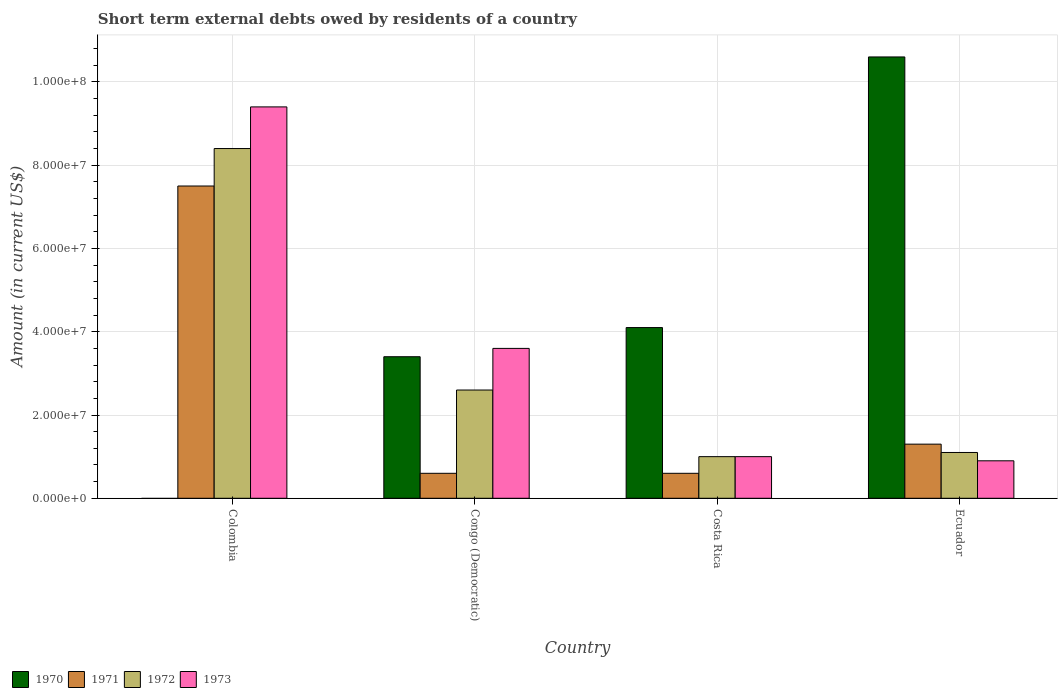How many different coloured bars are there?
Provide a succinct answer. 4. How many groups of bars are there?
Make the answer very short. 4. What is the label of the 4th group of bars from the left?
Provide a succinct answer. Ecuador. Across all countries, what is the maximum amount of short-term external debts owed by residents in 1973?
Your answer should be compact. 9.40e+07. Across all countries, what is the minimum amount of short-term external debts owed by residents in 1970?
Ensure brevity in your answer.  0. What is the total amount of short-term external debts owed by residents in 1972 in the graph?
Give a very brief answer. 1.31e+08. What is the difference between the amount of short-term external debts owed by residents in 1973 in Colombia and that in Ecuador?
Offer a very short reply. 8.50e+07. What is the difference between the amount of short-term external debts owed by residents in 1970 in Congo (Democratic) and the amount of short-term external debts owed by residents in 1973 in Colombia?
Ensure brevity in your answer.  -6.00e+07. What is the average amount of short-term external debts owed by residents in 1973 per country?
Ensure brevity in your answer.  3.72e+07. What is the difference between the amount of short-term external debts owed by residents of/in 1972 and amount of short-term external debts owed by residents of/in 1973 in Colombia?
Make the answer very short. -1.00e+07. In how many countries, is the amount of short-term external debts owed by residents in 1971 greater than 92000000 US$?
Ensure brevity in your answer.  0. What is the ratio of the amount of short-term external debts owed by residents in 1970 in Costa Rica to that in Ecuador?
Make the answer very short. 0.39. Is the amount of short-term external debts owed by residents in 1973 in Costa Rica less than that in Ecuador?
Offer a terse response. No. What is the difference between the highest and the second highest amount of short-term external debts owed by residents in 1973?
Give a very brief answer. 5.80e+07. What is the difference between the highest and the lowest amount of short-term external debts owed by residents in 1970?
Offer a terse response. 1.06e+08. Is it the case that in every country, the sum of the amount of short-term external debts owed by residents in 1973 and amount of short-term external debts owed by residents in 1972 is greater than the sum of amount of short-term external debts owed by residents in 1970 and amount of short-term external debts owed by residents in 1971?
Provide a short and direct response. No. How many bars are there?
Ensure brevity in your answer.  15. How many countries are there in the graph?
Your response must be concise. 4. What is the difference between two consecutive major ticks on the Y-axis?
Make the answer very short. 2.00e+07. Where does the legend appear in the graph?
Offer a terse response. Bottom left. How many legend labels are there?
Your answer should be very brief. 4. What is the title of the graph?
Make the answer very short. Short term external debts owed by residents of a country. Does "2011" appear as one of the legend labels in the graph?
Offer a terse response. No. What is the Amount (in current US$) of 1970 in Colombia?
Ensure brevity in your answer.  0. What is the Amount (in current US$) in 1971 in Colombia?
Your answer should be compact. 7.50e+07. What is the Amount (in current US$) of 1972 in Colombia?
Your response must be concise. 8.40e+07. What is the Amount (in current US$) of 1973 in Colombia?
Offer a terse response. 9.40e+07. What is the Amount (in current US$) of 1970 in Congo (Democratic)?
Your answer should be compact. 3.40e+07. What is the Amount (in current US$) of 1972 in Congo (Democratic)?
Give a very brief answer. 2.60e+07. What is the Amount (in current US$) in 1973 in Congo (Democratic)?
Provide a succinct answer. 3.60e+07. What is the Amount (in current US$) in 1970 in Costa Rica?
Your answer should be very brief. 4.10e+07. What is the Amount (in current US$) of 1971 in Costa Rica?
Offer a very short reply. 6.00e+06. What is the Amount (in current US$) of 1972 in Costa Rica?
Your answer should be very brief. 1.00e+07. What is the Amount (in current US$) of 1970 in Ecuador?
Offer a terse response. 1.06e+08. What is the Amount (in current US$) of 1971 in Ecuador?
Offer a terse response. 1.30e+07. What is the Amount (in current US$) in 1972 in Ecuador?
Your answer should be compact. 1.10e+07. What is the Amount (in current US$) in 1973 in Ecuador?
Make the answer very short. 9.00e+06. Across all countries, what is the maximum Amount (in current US$) of 1970?
Your answer should be compact. 1.06e+08. Across all countries, what is the maximum Amount (in current US$) of 1971?
Give a very brief answer. 7.50e+07. Across all countries, what is the maximum Amount (in current US$) of 1972?
Offer a very short reply. 8.40e+07. Across all countries, what is the maximum Amount (in current US$) of 1973?
Keep it short and to the point. 9.40e+07. Across all countries, what is the minimum Amount (in current US$) in 1972?
Provide a short and direct response. 1.00e+07. Across all countries, what is the minimum Amount (in current US$) of 1973?
Your answer should be compact. 9.00e+06. What is the total Amount (in current US$) of 1970 in the graph?
Provide a succinct answer. 1.81e+08. What is the total Amount (in current US$) of 1971 in the graph?
Make the answer very short. 1.00e+08. What is the total Amount (in current US$) of 1972 in the graph?
Ensure brevity in your answer.  1.31e+08. What is the total Amount (in current US$) of 1973 in the graph?
Ensure brevity in your answer.  1.49e+08. What is the difference between the Amount (in current US$) of 1971 in Colombia and that in Congo (Democratic)?
Your answer should be very brief. 6.90e+07. What is the difference between the Amount (in current US$) of 1972 in Colombia and that in Congo (Democratic)?
Provide a succinct answer. 5.80e+07. What is the difference between the Amount (in current US$) in 1973 in Colombia and that in Congo (Democratic)?
Provide a short and direct response. 5.80e+07. What is the difference between the Amount (in current US$) in 1971 in Colombia and that in Costa Rica?
Give a very brief answer. 6.90e+07. What is the difference between the Amount (in current US$) in 1972 in Colombia and that in Costa Rica?
Your response must be concise. 7.40e+07. What is the difference between the Amount (in current US$) of 1973 in Colombia and that in Costa Rica?
Your answer should be very brief. 8.40e+07. What is the difference between the Amount (in current US$) of 1971 in Colombia and that in Ecuador?
Provide a succinct answer. 6.20e+07. What is the difference between the Amount (in current US$) in 1972 in Colombia and that in Ecuador?
Make the answer very short. 7.30e+07. What is the difference between the Amount (in current US$) in 1973 in Colombia and that in Ecuador?
Make the answer very short. 8.50e+07. What is the difference between the Amount (in current US$) in 1970 in Congo (Democratic) and that in Costa Rica?
Your answer should be compact. -7.00e+06. What is the difference between the Amount (in current US$) of 1971 in Congo (Democratic) and that in Costa Rica?
Give a very brief answer. 0. What is the difference between the Amount (in current US$) of 1972 in Congo (Democratic) and that in Costa Rica?
Your answer should be very brief. 1.60e+07. What is the difference between the Amount (in current US$) in 1973 in Congo (Democratic) and that in Costa Rica?
Provide a short and direct response. 2.60e+07. What is the difference between the Amount (in current US$) of 1970 in Congo (Democratic) and that in Ecuador?
Your response must be concise. -7.20e+07. What is the difference between the Amount (in current US$) in 1971 in Congo (Democratic) and that in Ecuador?
Provide a short and direct response. -7.00e+06. What is the difference between the Amount (in current US$) of 1972 in Congo (Democratic) and that in Ecuador?
Make the answer very short. 1.50e+07. What is the difference between the Amount (in current US$) in 1973 in Congo (Democratic) and that in Ecuador?
Ensure brevity in your answer.  2.70e+07. What is the difference between the Amount (in current US$) in 1970 in Costa Rica and that in Ecuador?
Offer a terse response. -6.50e+07. What is the difference between the Amount (in current US$) in 1971 in Costa Rica and that in Ecuador?
Ensure brevity in your answer.  -7.00e+06. What is the difference between the Amount (in current US$) of 1972 in Costa Rica and that in Ecuador?
Ensure brevity in your answer.  -1.00e+06. What is the difference between the Amount (in current US$) in 1971 in Colombia and the Amount (in current US$) in 1972 in Congo (Democratic)?
Ensure brevity in your answer.  4.90e+07. What is the difference between the Amount (in current US$) in 1971 in Colombia and the Amount (in current US$) in 1973 in Congo (Democratic)?
Offer a terse response. 3.90e+07. What is the difference between the Amount (in current US$) of 1972 in Colombia and the Amount (in current US$) of 1973 in Congo (Democratic)?
Ensure brevity in your answer.  4.80e+07. What is the difference between the Amount (in current US$) of 1971 in Colombia and the Amount (in current US$) of 1972 in Costa Rica?
Offer a terse response. 6.50e+07. What is the difference between the Amount (in current US$) of 1971 in Colombia and the Amount (in current US$) of 1973 in Costa Rica?
Give a very brief answer. 6.50e+07. What is the difference between the Amount (in current US$) of 1972 in Colombia and the Amount (in current US$) of 1973 in Costa Rica?
Provide a short and direct response. 7.40e+07. What is the difference between the Amount (in current US$) of 1971 in Colombia and the Amount (in current US$) of 1972 in Ecuador?
Your answer should be compact. 6.40e+07. What is the difference between the Amount (in current US$) of 1971 in Colombia and the Amount (in current US$) of 1973 in Ecuador?
Your response must be concise. 6.60e+07. What is the difference between the Amount (in current US$) of 1972 in Colombia and the Amount (in current US$) of 1973 in Ecuador?
Offer a very short reply. 7.50e+07. What is the difference between the Amount (in current US$) in 1970 in Congo (Democratic) and the Amount (in current US$) in 1971 in Costa Rica?
Give a very brief answer. 2.80e+07. What is the difference between the Amount (in current US$) of 1970 in Congo (Democratic) and the Amount (in current US$) of 1972 in Costa Rica?
Your answer should be compact. 2.40e+07. What is the difference between the Amount (in current US$) in 1970 in Congo (Democratic) and the Amount (in current US$) in 1973 in Costa Rica?
Your response must be concise. 2.40e+07. What is the difference between the Amount (in current US$) of 1972 in Congo (Democratic) and the Amount (in current US$) of 1973 in Costa Rica?
Give a very brief answer. 1.60e+07. What is the difference between the Amount (in current US$) in 1970 in Congo (Democratic) and the Amount (in current US$) in 1971 in Ecuador?
Provide a succinct answer. 2.10e+07. What is the difference between the Amount (in current US$) of 1970 in Congo (Democratic) and the Amount (in current US$) of 1972 in Ecuador?
Offer a terse response. 2.30e+07. What is the difference between the Amount (in current US$) of 1970 in Congo (Democratic) and the Amount (in current US$) of 1973 in Ecuador?
Your answer should be very brief. 2.50e+07. What is the difference between the Amount (in current US$) of 1971 in Congo (Democratic) and the Amount (in current US$) of 1972 in Ecuador?
Your answer should be very brief. -5.00e+06. What is the difference between the Amount (in current US$) in 1972 in Congo (Democratic) and the Amount (in current US$) in 1973 in Ecuador?
Offer a terse response. 1.70e+07. What is the difference between the Amount (in current US$) in 1970 in Costa Rica and the Amount (in current US$) in 1971 in Ecuador?
Your response must be concise. 2.80e+07. What is the difference between the Amount (in current US$) of 1970 in Costa Rica and the Amount (in current US$) of 1972 in Ecuador?
Your response must be concise. 3.00e+07. What is the difference between the Amount (in current US$) in 1970 in Costa Rica and the Amount (in current US$) in 1973 in Ecuador?
Your answer should be compact. 3.20e+07. What is the difference between the Amount (in current US$) in 1971 in Costa Rica and the Amount (in current US$) in 1972 in Ecuador?
Offer a terse response. -5.00e+06. What is the difference between the Amount (in current US$) of 1971 in Costa Rica and the Amount (in current US$) of 1973 in Ecuador?
Provide a succinct answer. -3.00e+06. What is the difference between the Amount (in current US$) in 1972 in Costa Rica and the Amount (in current US$) in 1973 in Ecuador?
Offer a terse response. 1.00e+06. What is the average Amount (in current US$) of 1970 per country?
Offer a terse response. 4.52e+07. What is the average Amount (in current US$) of 1971 per country?
Keep it short and to the point. 2.50e+07. What is the average Amount (in current US$) in 1972 per country?
Provide a short and direct response. 3.28e+07. What is the average Amount (in current US$) in 1973 per country?
Make the answer very short. 3.72e+07. What is the difference between the Amount (in current US$) in 1971 and Amount (in current US$) in 1972 in Colombia?
Provide a succinct answer. -9.00e+06. What is the difference between the Amount (in current US$) in 1971 and Amount (in current US$) in 1973 in Colombia?
Offer a very short reply. -1.90e+07. What is the difference between the Amount (in current US$) of 1972 and Amount (in current US$) of 1973 in Colombia?
Your answer should be compact. -1.00e+07. What is the difference between the Amount (in current US$) of 1970 and Amount (in current US$) of 1971 in Congo (Democratic)?
Offer a very short reply. 2.80e+07. What is the difference between the Amount (in current US$) of 1970 and Amount (in current US$) of 1972 in Congo (Democratic)?
Your answer should be compact. 8.00e+06. What is the difference between the Amount (in current US$) in 1971 and Amount (in current US$) in 1972 in Congo (Democratic)?
Ensure brevity in your answer.  -2.00e+07. What is the difference between the Amount (in current US$) in 1971 and Amount (in current US$) in 1973 in Congo (Democratic)?
Ensure brevity in your answer.  -3.00e+07. What is the difference between the Amount (in current US$) in 1972 and Amount (in current US$) in 1973 in Congo (Democratic)?
Provide a succinct answer. -1.00e+07. What is the difference between the Amount (in current US$) of 1970 and Amount (in current US$) of 1971 in Costa Rica?
Your answer should be very brief. 3.50e+07. What is the difference between the Amount (in current US$) in 1970 and Amount (in current US$) in 1972 in Costa Rica?
Make the answer very short. 3.10e+07. What is the difference between the Amount (in current US$) in 1970 and Amount (in current US$) in 1973 in Costa Rica?
Offer a very short reply. 3.10e+07. What is the difference between the Amount (in current US$) in 1972 and Amount (in current US$) in 1973 in Costa Rica?
Provide a succinct answer. 0. What is the difference between the Amount (in current US$) of 1970 and Amount (in current US$) of 1971 in Ecuador?
Ensure brevity in your answer.  9.30e+07. What is the difference between the Amount (in current US$) in 1970 and Amount (in current US$) in 1972 in Ecuador?
Give a very brief answer. 9.50e+07. What is the difference between the Amount (in current US$) in 1970 and Amount (in current US$) in 1973 in Ecuador?
Provide a succinct answer. 9.70e+07. What is the difference between the Amount (in current US$) in 1971 and Amount (in current US$) in 1972 in Ecuador?
Your answer should be very brief. 2.00e+06. What is the difference between the Amount (in current US$) in 1972 and Amount (in current US$) in 1973 in Ecuador?
Your answer should be compact. 2.00e+06. What is the ratio of the Amount (in current US$) in 1971 in Colombia to that in Congo (Democratic)?
Make the answer very short. 12.5. What is the ratio of the Amount (in current US$) in 1972 in Colombia to that in Congo (Democratic)?
Make the answer very short. 3.23. What is the ratio of the Amount (in current US$) in 1973 in Colombia to that in Congo (Democratic)?
Your answer should be compact. 2.61. What is the ratio of the Amount (in current US$) in 1972 in Colombia to that in Costa Rica?
Give a very brief answer. 8.4. What is the ratio of the Amount (in current US$) of 1971 in Colombia to that in Ecuador?
Give a very brief answer. 5.77. What is the ratio of the Amount (in current US$) in 1972 in Colombia to that in Ecuador?
Offer a terse response. 7.64. What is the ratio of the Amount (in current US$) of 1973 in Colombia to that in Ecuador?
Provide a short and direct response. 10.44. What is the ratio of the Amount (in current US$) of 1970 in Congo (Democratic) to that in Costa Rica?
Your response must be concise. 0.83. What is the ratio of the Amount (in current US$) in 1972 in Congo (Democratic) to that in Costa Rica?
Ensure brevity in your answer.  2.6. What is the ratio of the Amount (in current US$) in 1973 in Congo (Democratic) to that in Costa Rica?
Provide a short and direct response. 3.6. What is the ratio of the Amount (in current US$) in 1970 in Congo (Democratic) to that in Ecuador?
Offer a very short reply. 0.32. What is the ratio of the Amount (in current US$) in 1971 in Congo (Democratic) to that in Ecuador?
Make the answer very short. 0.46. What is the ratio of the Amount (in current US$) in 1972 in Congo (Democratic) to that in Ecuador?
Offer a terse response. 2.36. What is the ratio of the Amount (in current US$) in 1970 in Costa Rica to that in Ecuador?
Offer a terse response. 0.39. What is the ratio of the Amount (in current US$) in 1971 in Costa Rica to that in Ecuador?
Your answer should be very brief. 0.46. What is the ratio of the Amount (in current US$) in 1973 in Costa Rica to that in Ecuador?
Ensure brevity in your answer.  1.11. What is the difference between the highest and the second highest Amount (in current US$) of 1970?
Provide a short and direct response. 6.50e+07. What is the difference between the highest and the second highest Amount (in current US$) of 1971?
Provide a succinct answer. 6.20e+07. What is the difference between the highest and the second highest Amount (in current US$) of 1972?
Offer a very short reply. 5.80e+07. What is the difference between the highest and the second highest Amount (in current US$) of 1973?
Offer a very short reply. 5.80e+07. What is the difference between the highest and the lowest Amount (in current US$) of 1970?
Provide a succinct answer. 1.06e+08. What is the difference between the highest and the lowest Amount (in current US$) of 1971?
Make the answer very short. 6.90e+07. What is the difference between the highest and the lowest Amount (in current US$) of 1972?
Give a very brief answer. 7.40e+07. What is the difference between the highest and the lowest Amount (in current US$) of 1973?
Offer a very short reply. 8.50e+07. 